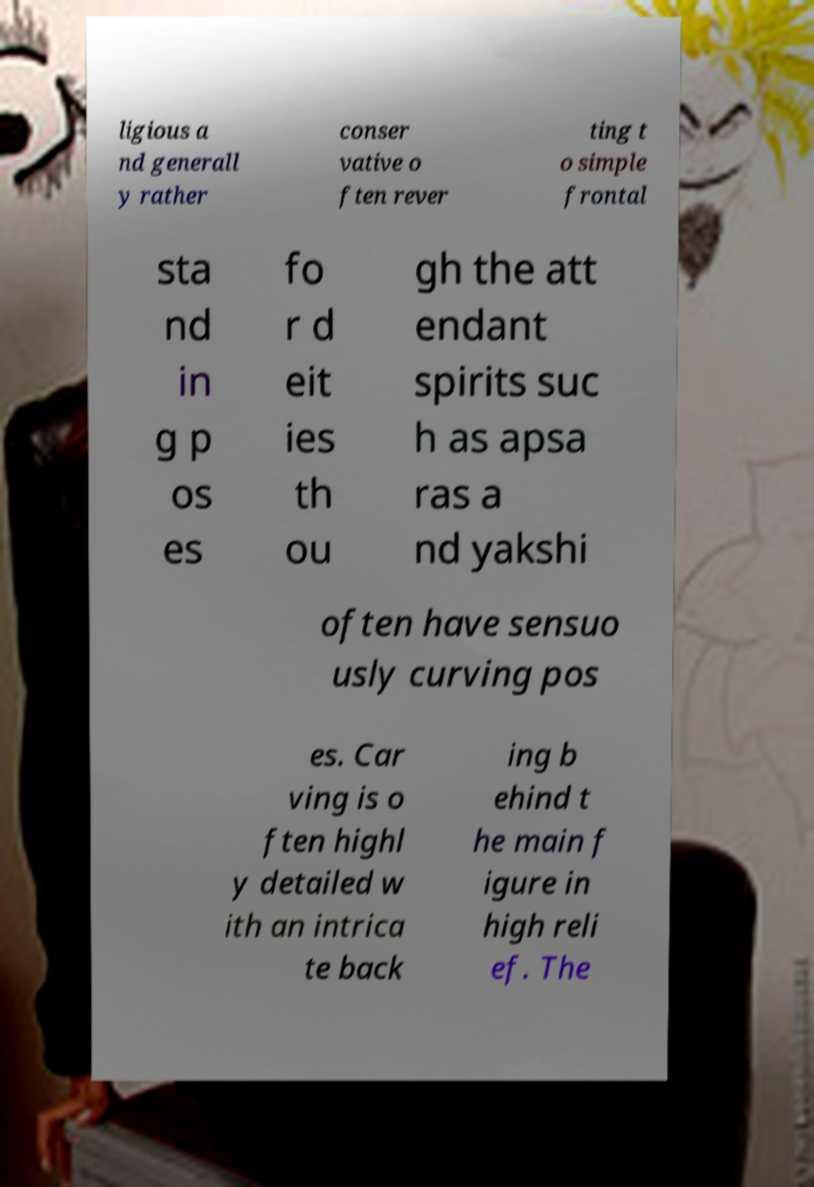Could you extract and type out the text from this image? ligious a nd generall y rather conser vative o ften rever ting t o simple frontal sta nd in g p os es fo r d eit ies th ou gh the att endant spirits suc h as apsa ras a nd yakshi often have sensuo usly curving pos es. Car ving is o ften highl y detailed w ith an intrica te back ing b ehind t he main f igure in high reli ef. The 